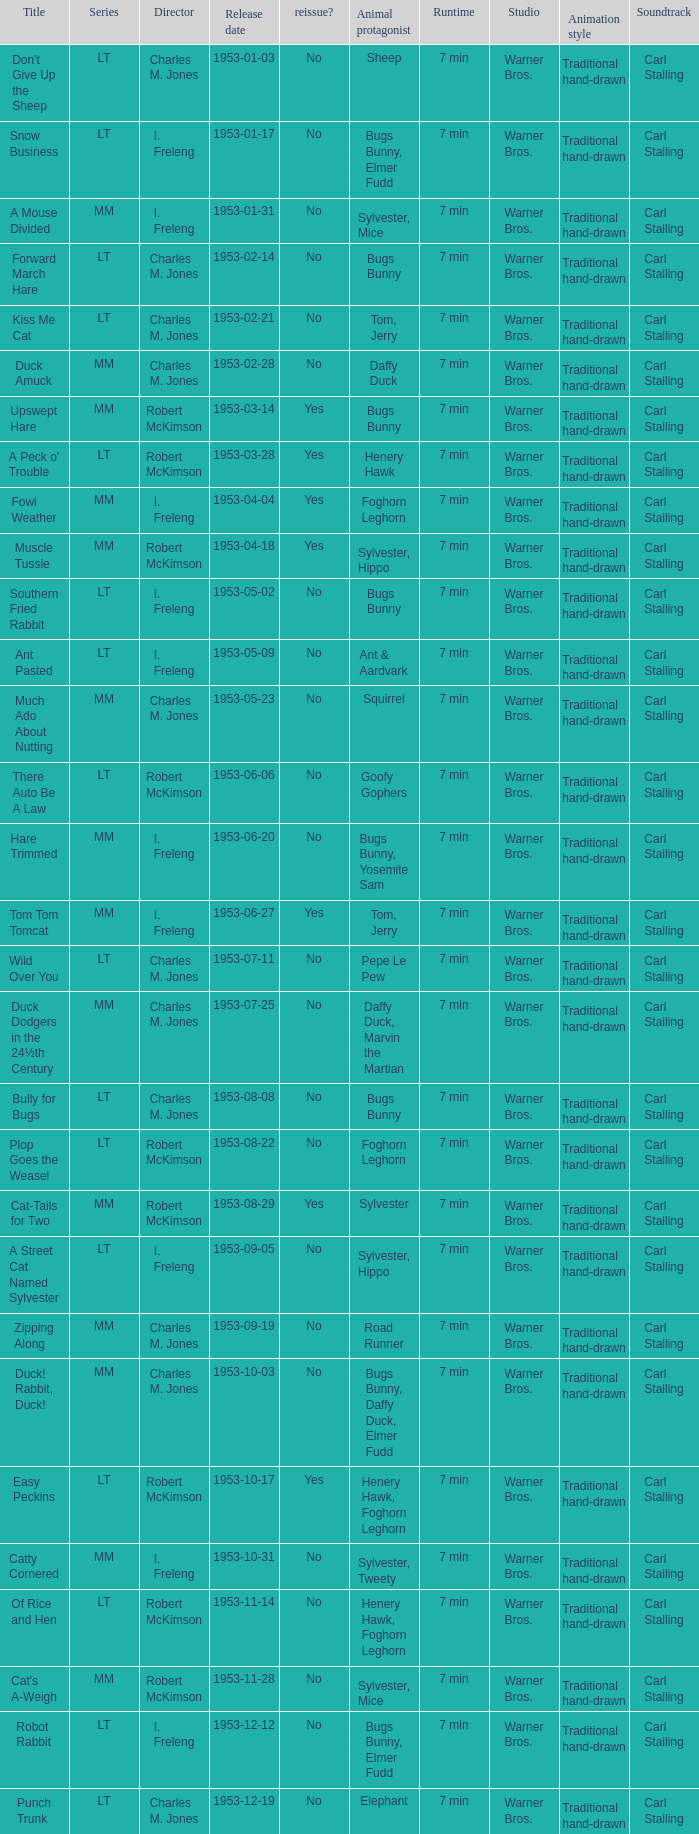What's the release date of Upswept Hare? 1953-03-14. 